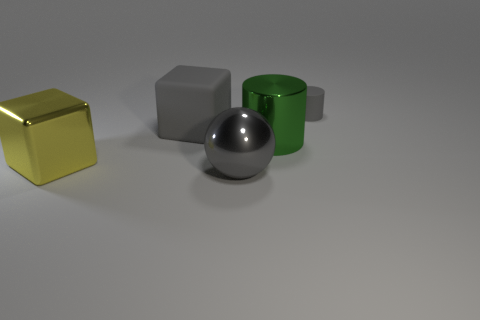What is the material of the gray object that is both behind the yellow object and in front of the small rubber thing?
Provide a succinct answer. Rubber. Does the rubber thing in front of the tiny gray matte thing have the same color as the tiny object?
Your answer should be very brief. Yes. Do the tiny cylinder and the cylinder that is in front of the gray cylinder have the same color?
Your response must be concise. No. There is a large yellow metal object; are there any things behind it?
Provide a short and direct response. Yes. Is the material of the green thing the same as the yellow block?
Keep it short and to the point. Yes. What is the material of the other cube that is the same size as the gray matte cube?
Your response must be concise. Metal. What number of things are either big shiny things right of the large metallic ball or large cyan metal things?
Offer a terse response. 1. Is the number of big matte objects that are behind the gray cylinder the same as the number of large gray metallic spheres?
Offer a very short reply. No. Does the metallic block have the same color as the small object?
Give a very brief answer. No. There is a thing that is both in front of the matte block and to the left of the gray sphere; what color is it?
Ensure brevity in your answer.  Yellow. 